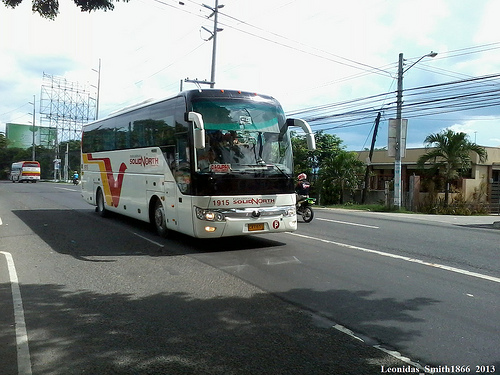Please provide the bounding box coordinate of the region this sentence describes: many utility lines run along the side of the street. 'The bounding box for the region showing many utility lines running along the side of the street should be approximately from (0.62, 0.28) to (0.99, 0.39). 